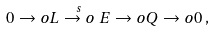Convert formula to latex. <formula><loc_0><loc_0><loc_500><loc_500>0 \to o L \stackrel { s } { \to o } E \to o Q \to o 0 \, ,</formula> 